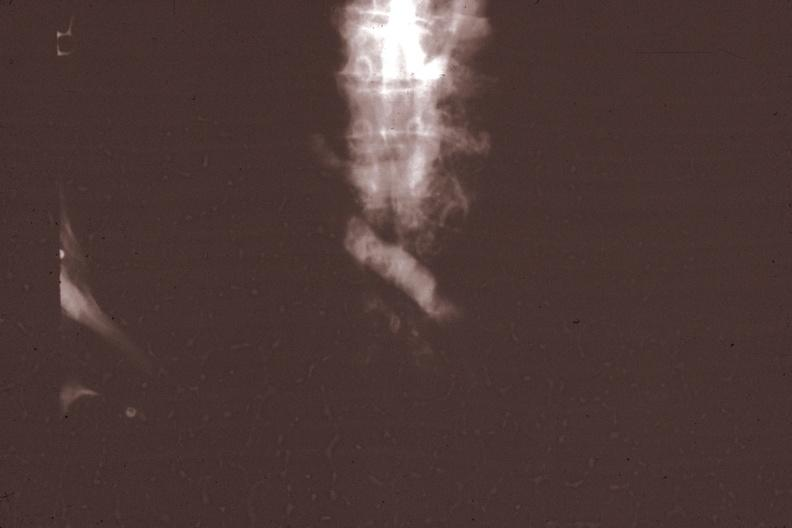what corresponds?
Answer the question using a single word or phrase. X-ray super cava venogram showing obstruction at level of entrance of innominate vein gross photo of tumor in this file 